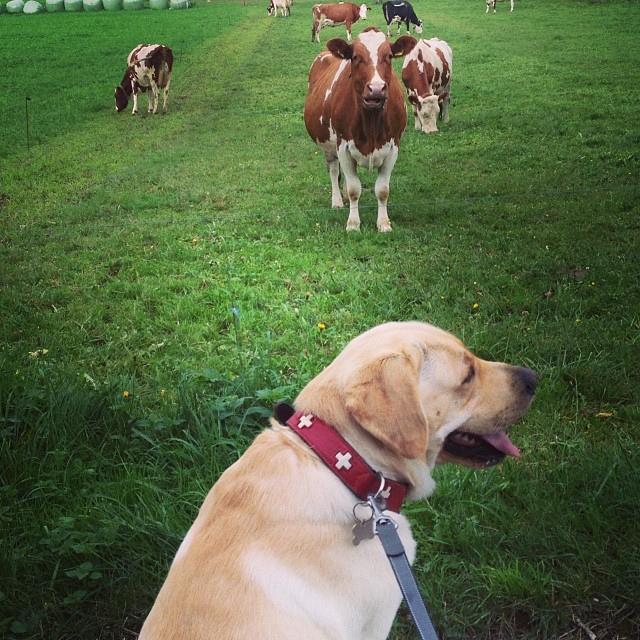Which holiday season is it?
Quick response, please. Summer. What kind of dog is this?
Give a very brief answer. Lab. Is the cow pregnant?
Quick response, please. Yes. Is the dog agitated?
Answer briefly. No. 